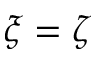Convert formula to latex. <formula><loc_0><loc_0><loc_500><loc_500>\xi = \zeta</formula> 